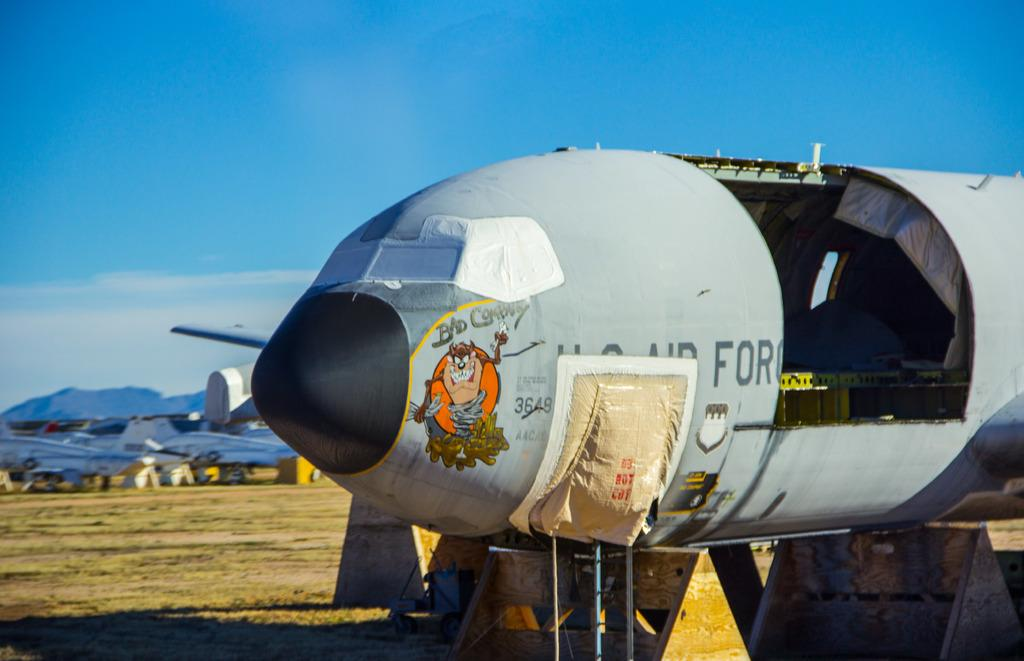<image>
Create a compact narrative representing the image presented. An old U.S. Air Force plane is called Bad Company and features a picture of the Tasmanian Devil cartoon character. 